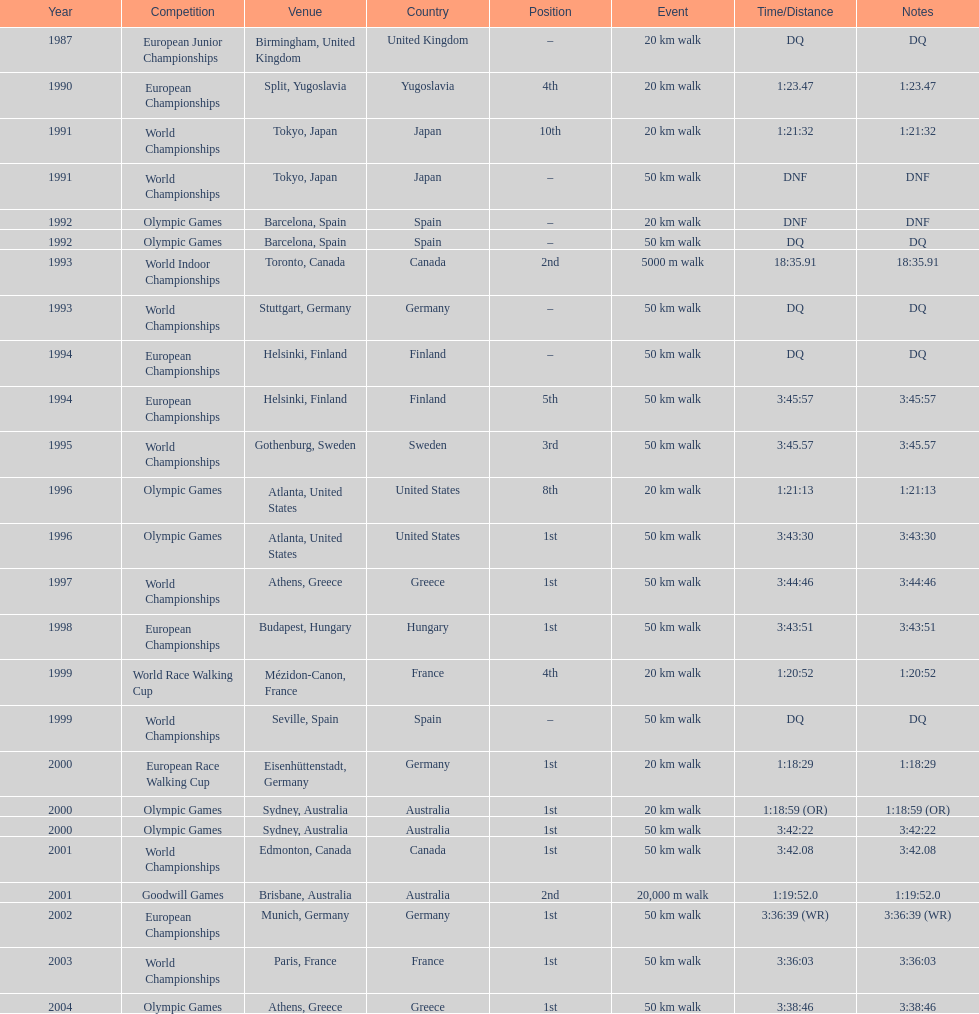How many events were at least 50 km? 17. 